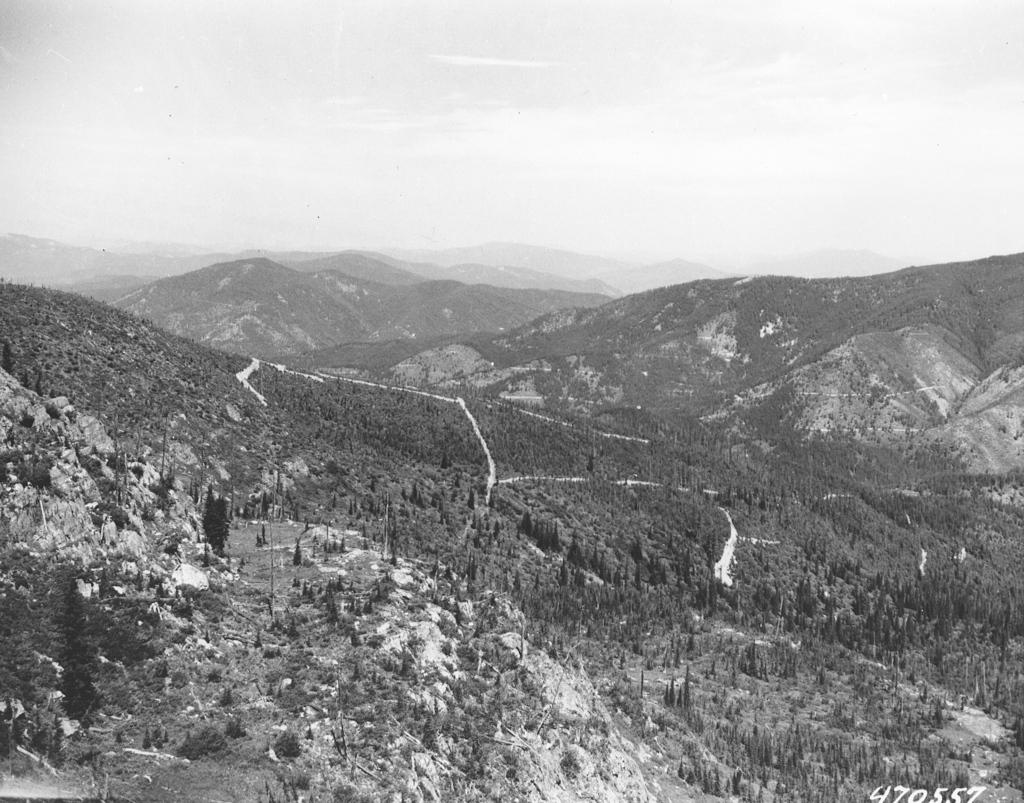What type of natural features can be seen at the bottom of the image? There are trees and mountains at the bottom of the image. Are there any mountains visible in other parts of the image? Yes, there are mountains in the background of the image. What is visible at the top of the image? The sky is visible at the top of the image. What type of tin can be seen in the image? There is no tin present in the image. Can you see a friend in the image? There is no friend visible in the image. 